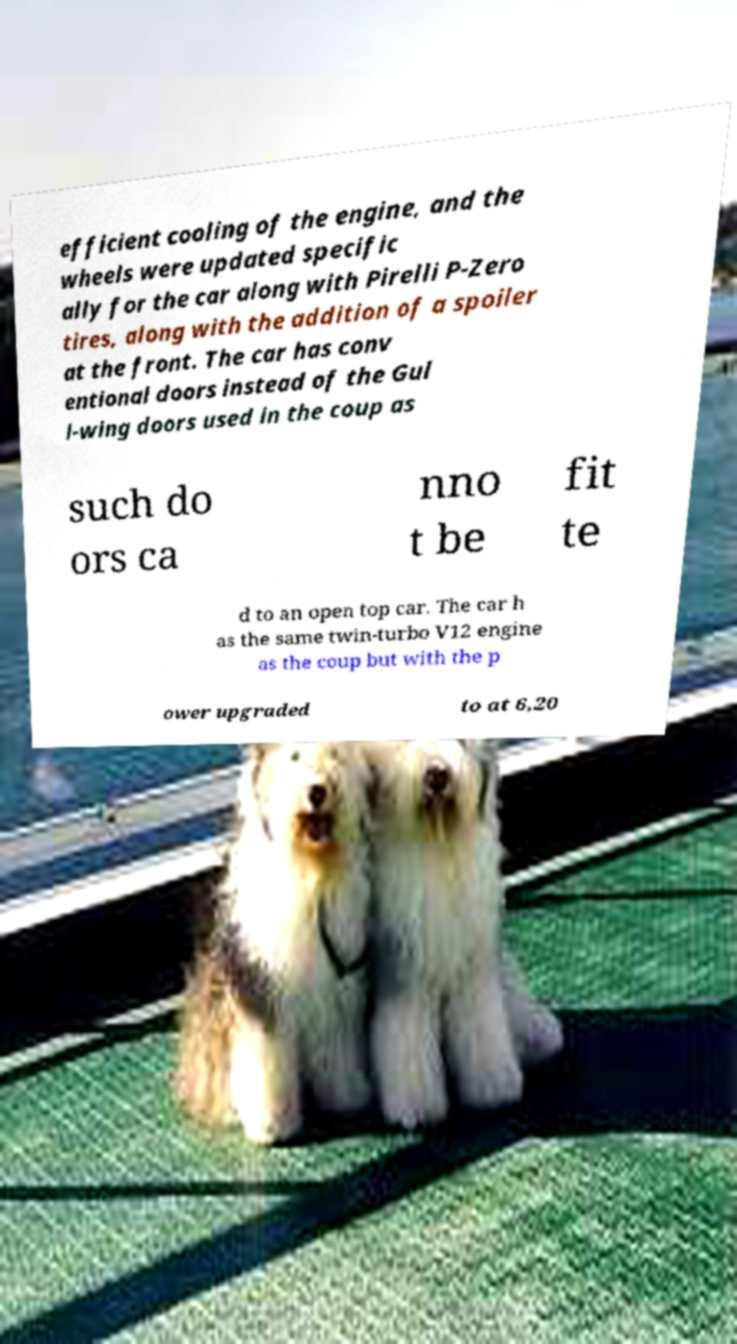What messages or text are displayed in this image? I need them in a readable, typed format. efficient cooling of the engine, and the wheels were updated specific ally for the car along with Pirelli P-Zero tires, along with the addition of a spoiler at the front. The car has conv entional doors instead of the Gul l-wing doors used in the coup as such do ors ca nno t be fit te d to an open top car. The car h as the same twin-turbo V12 engine as the coup but with the p ower upgraded to at 6,20 